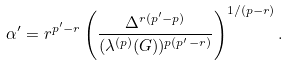<formula> <loc_0><loc_0><loc_500><loc_500>\alpha ^ { \prime } = r ^ { p ^ { \prime } - r } \left ( \frac { \Delta ^ { r ( p ^ { \prime } - p ) } } { ( \lambda ^ { ( p ) } ( G ) ) ^ { p ( p ^ { \prime } - r ) } } \right ) ^ { 1 / ( p - r ) } .</formula> 